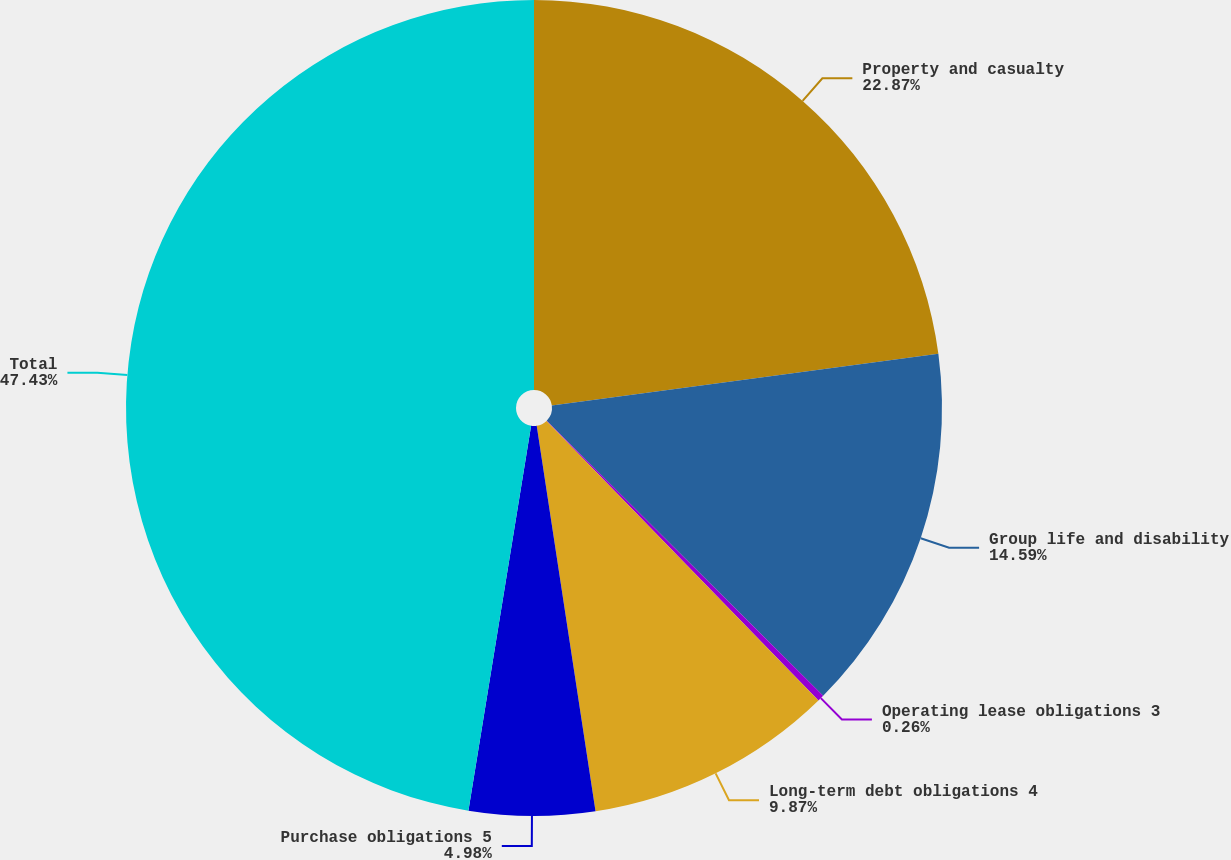Convert chart. <chart><loc_0><loc_0><loc_500><loc_500><pie_chart><fcel>Property and casualty<fcel>Group life and disability<fcel>Operating lease obligations 3<fcel>Long-term debt obligations 4<fcel>Purchase obligations 5<fcel>Total<nl><fcel>22.88%<fcel>14.59%<fcel>0.26%<fcel>9.87%<fcel>4.98%<fcel>47.44%<nl></chart> 